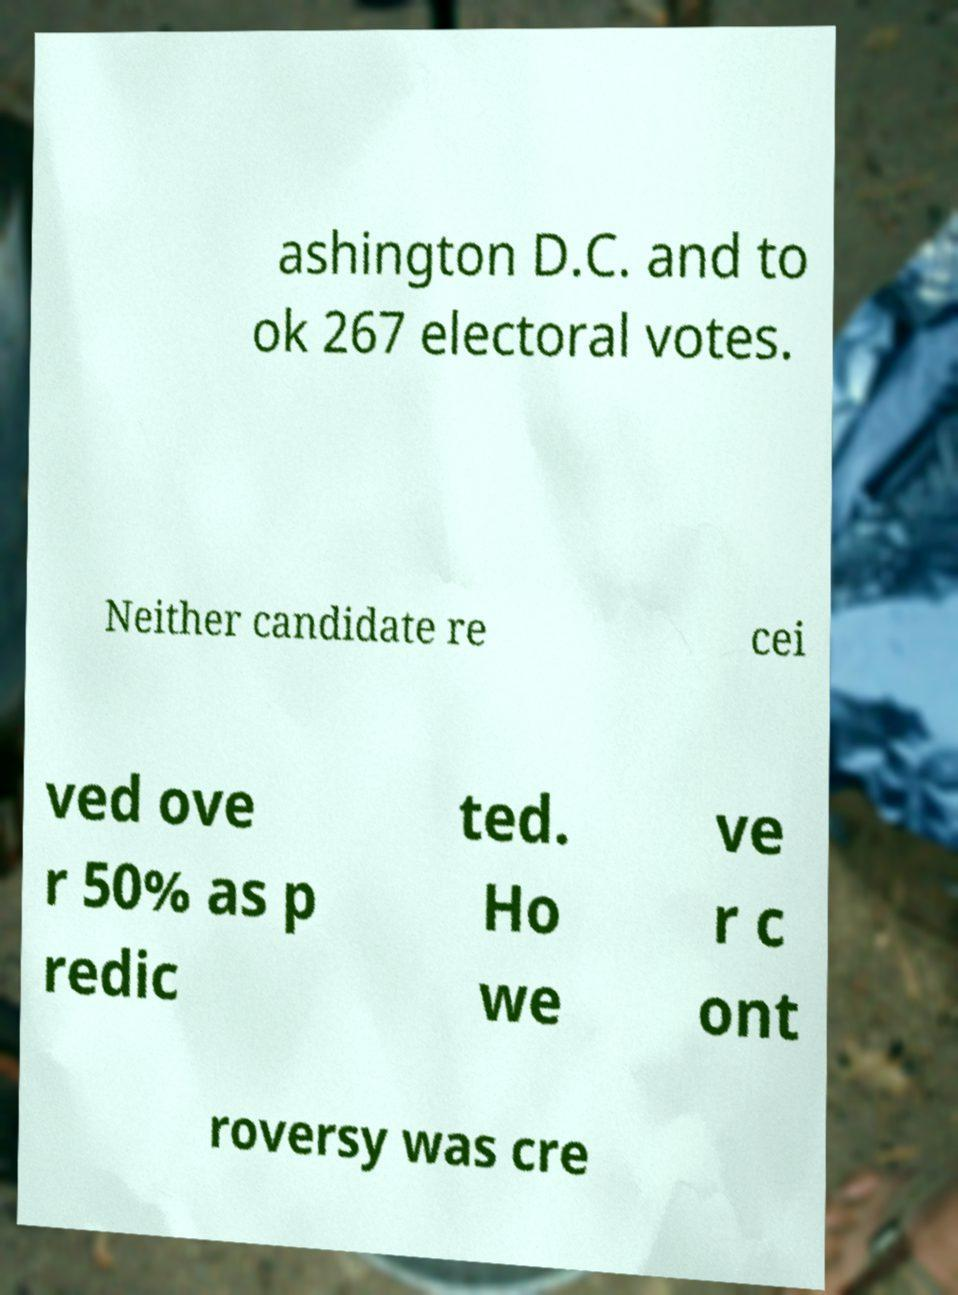For documentation purposes, I need the text within this image transcribed. Could you provide that? ashington D.C. and to ok 267 electoral votes. Neither candidate re cei ved ove r 50% as p redic ted. Ho we ve r c ont roversy was cre 